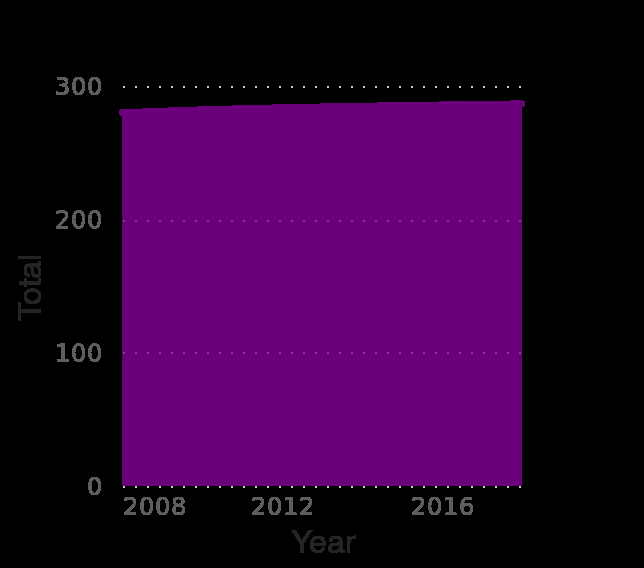<image>
Was there any change in the population of Barbados between 2008 and 2016?  Yes, the population of Barbados increased between 2008 and 2016. What does the area plot represent? The area plot represents the total population of Barbados from 2008 to 2018, categorized by gender (in 1,000 inhabitants). Did the population of Barbados increase or decrease between 2008 and 2016?  The population of Barbados increased between 2008 and 2016. 